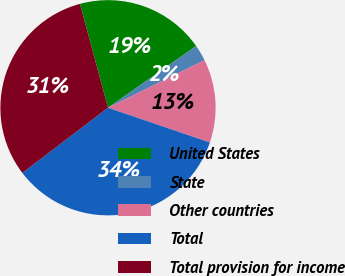<chart> <loc_0><loc_0><loc_500><loc_500><pie_chart><fcel>United States<fcel>State<fcel>Other countries<fcel>Total<fcel>Total provision for income<nl><fcel>19.47%<fcel>2.43%<fcel>12.52%<fcel>34.42%<fcel>31.15%<nl></chart> 